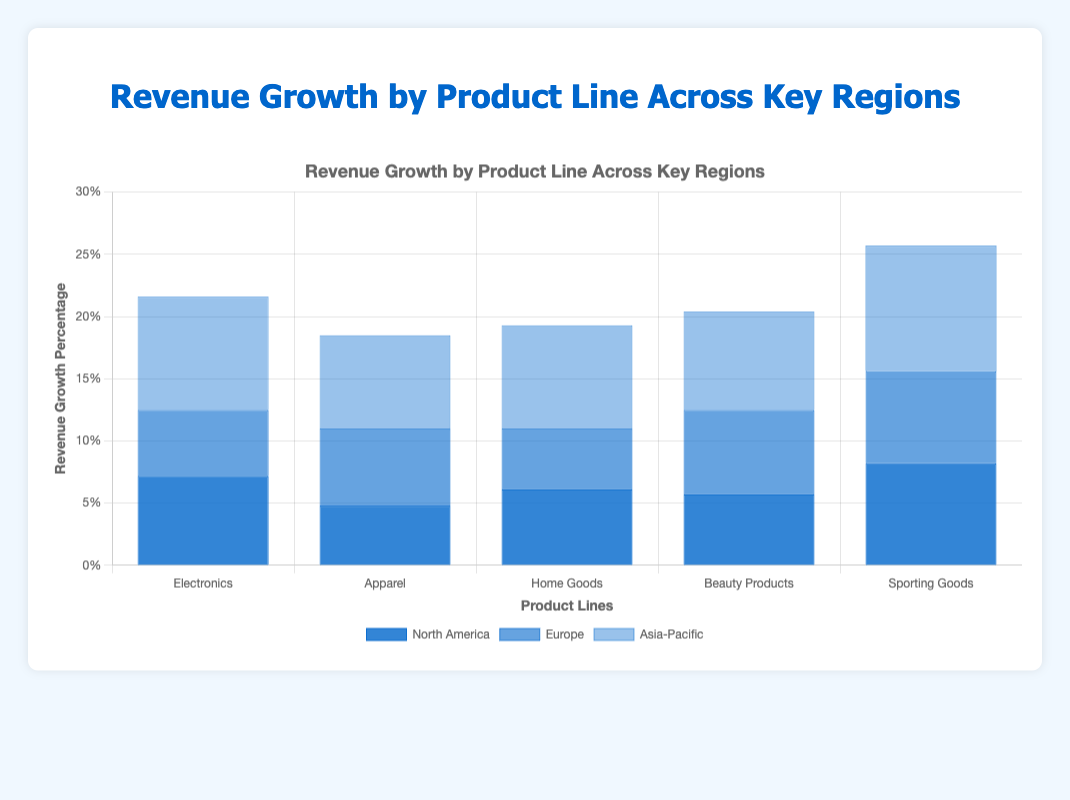Which Product Line in North America has the highest revenue growth percentage? From the bar chart, refer to the bars labeled "North America" and compare their heights. "Sporting Goods" has the tallest bar in North America.
Answer: Sporting Goods Which region has the highest revenue growth percentage for Electronics? Identify the bars for "Electronics" in the chart and compare the heights among the regions. The highest bar corresponds to the "Asia-Pacific" region.
Answer: Asia-Pacific What is the average revenue growth percentage for Home Goods across all regions? Calculate the average by summing the values for Home Goods (6.1, 4.9, and 8.3) and dividing by 3. (6.1 + 4.9 + 8.3) / 3 = 6.43.
Answer: 6.43% How does the revenue growth percentage for Apparel in Europe compare to that in Asia-Pacific? Check the bars labeled "Apparel" for Europe and Asia-Pacific, then compare their heights. Europe's bar is at 6.2% and Asia-Pacific's bar is at 7.5%.
Answer: Less than Asia-Pacific Which product line has the most consistent revenue growth across all regions? Look for a product line where the bars are most similar in height across North America, Europe, and Asia-Pacific. "Beauty Products" has bars of 5.7%, 6.8%, and 7.9%, which are relatively consistent compared to other product lines.
Answer: Beauty Products What is the total revenue growth percentage for Europe across all product lines? Sum the heights of all bars for Europe: (5.3 + 6.2 + 4.9 + 6.8 + 7.4). The total is 30.6%.
Answer: 30.6% Which region has the lowest overall revenue growth percentage for all product lines? Sum up the revenue growth percentages for each region:
North America: (7.2 + 4.8 + 6.1 + 5.7 + 8.2) = 32
Europe: (5.3 + 6.2 + 4.9 + 6.8 + 7.4) = 30.6 
Asia-Pacific: (9.1 + 7.5 + 8.3 + 7.9 + 10.1) = 42.9 
The lowest total is for Europe.
Answer: Europe What is the difference in revenue growth percentage for Sporting Goods between North America and Asia-Pacific? Subtract the North America value for Sporting Goods (8.2%) from the Asia-Pacific value (10.1%). 10.1 - 8.2 = 1.9%.
Answer: 1.9% Which product line has the highest combined revenue growth across all regions? Sum the revenue growth percentages for each product line:
Electronics: (7.2 + 5.3 + 9.1) = 21.6
Apparel: (4.8 + 6.2 + 7.5) = 18.5
Home Goods: (6.1 + 4.9 + 8.3) = 19.3
Beauty Products: (5.7 + 6.8 + 7.9) = 20.4
Sporting Goods: (8.2 + 7.4 + 10.1) = 25.7
Sporting Goods has the highest combined value of 25.7%.
Answer: Sporting Goods 